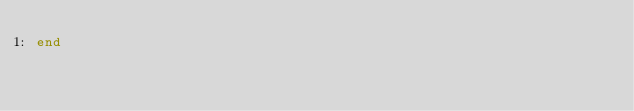Convert code to text. <code><loc_0><loc_0><loc_500><loc_500><_Ruby_>end
</code> 